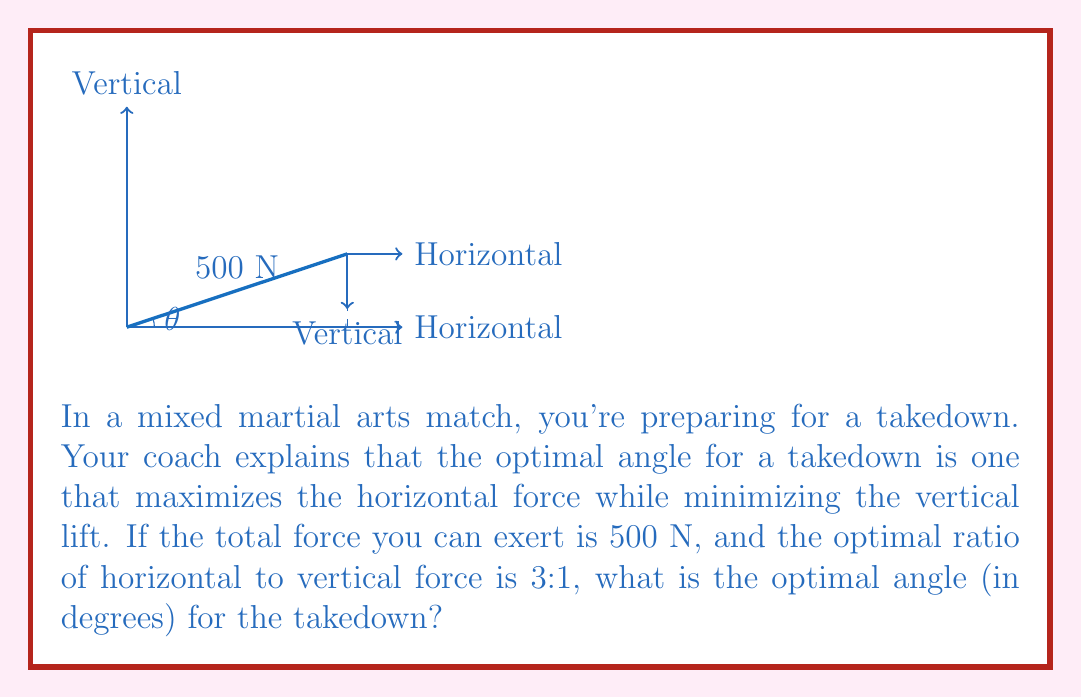Provide a solution to this math problem. Let's approach this step-by-step:

1) Let $\theta$ be the angle of the takedown force with respect to the horizontal.

2) The horizontal component of the force is $F_h = 500 \cos\theta$
   The vertical component of the force is $F_v = 500 \sin\theta$

3) We're told that the optimal ratio of horizontal to vertical force is 3:1. This means:

   $$\frac{F_h}{F_v} = \frac{500 \cos\theta}{500 \sin\theta} = \frac{\cos\theta}{\sin\theta} = \tan^{-1}\theta = 3$$

4) Now we can solve for $\theta$:

   $$\tan\theta = \frac{1}{3}$$

5) Taking the inverse tangent (arctangent) of both sides:

   $$\theta = \tan^{-1}(\frac{1}{3})$$

6) Converting to degrees:

   $$\theta = \tan^{-1}(\frac{1}{3}) \cdot \frac{180}{\pi} \approx 18.43^\circ$$

Thus, the optimal angle for the takedown is approximately 18.43 degrees.
Answer: $18.43^\circ$ 